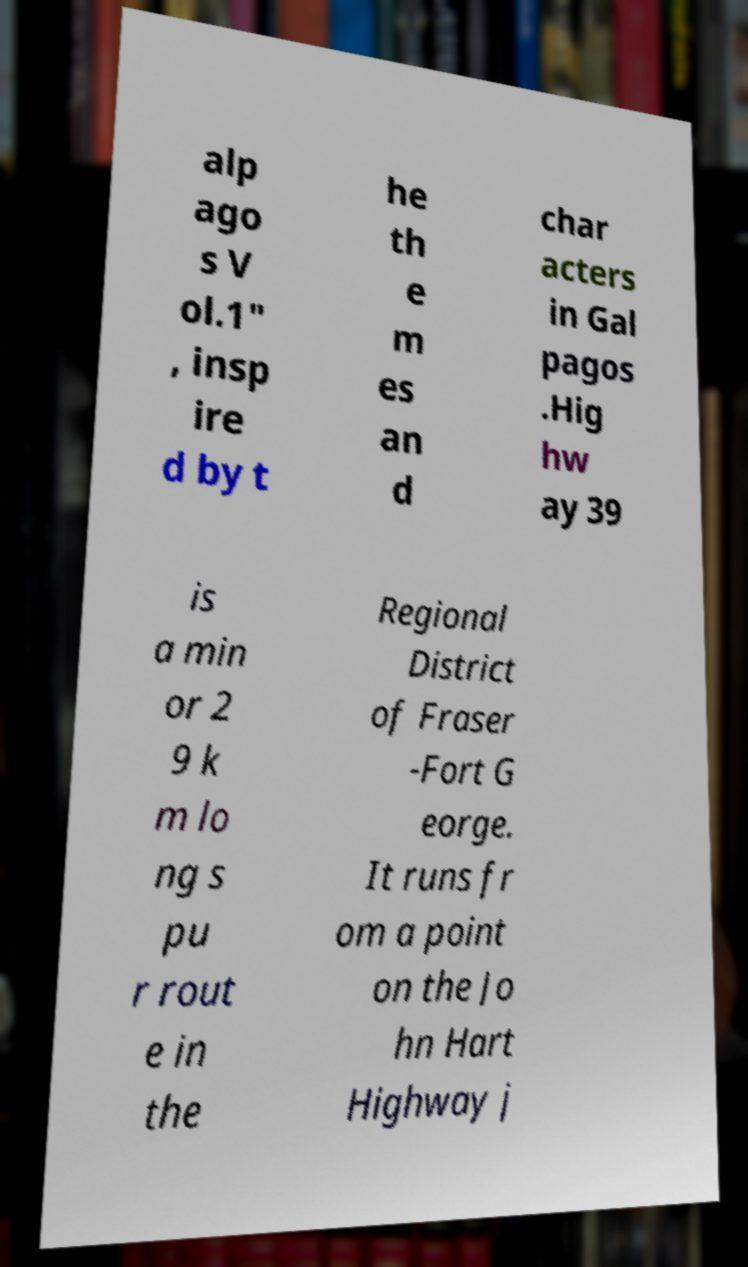Please identify and transcribe the text found in this image. alp ago s V ol.1" , insp ire d by t he th e m es an d char acters in Gal pagos .Hig hw ay 39 is a min or 2 9 k m lo ng s pu r rout e in the Regional District of Fraser -Fort G eorge. It runs fr om a point on the Jo hn Hart Highway j 